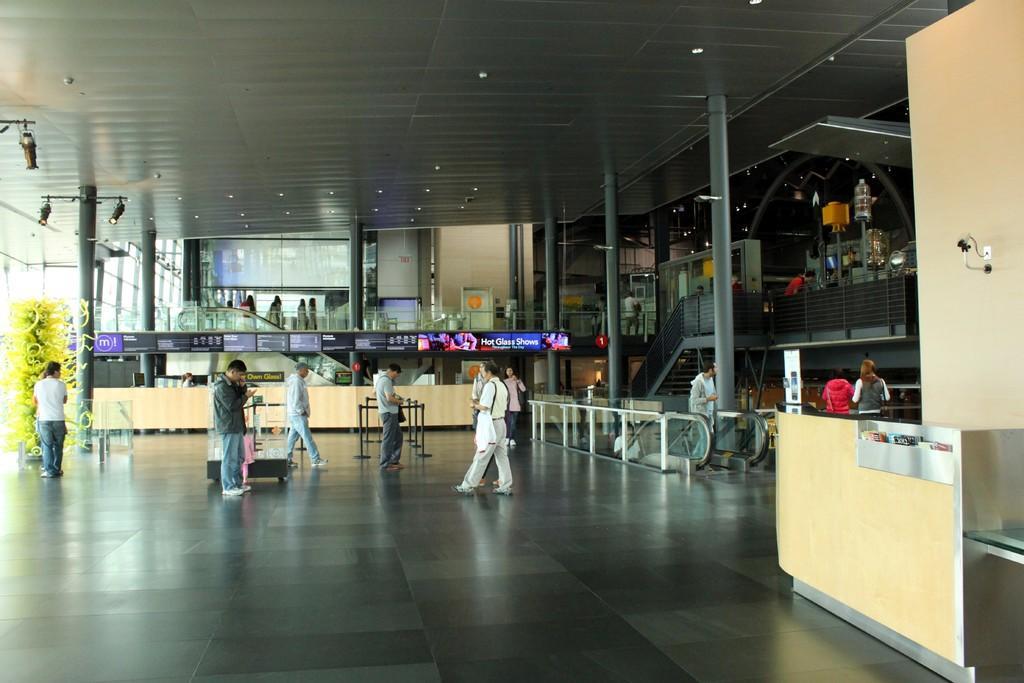Describe this image in one or two sentences. In the image we can see there are many people standing and some of them are walking, they are wearing clothes and shoes. This is a floor, wall, fence, pole, lights and a plant. 